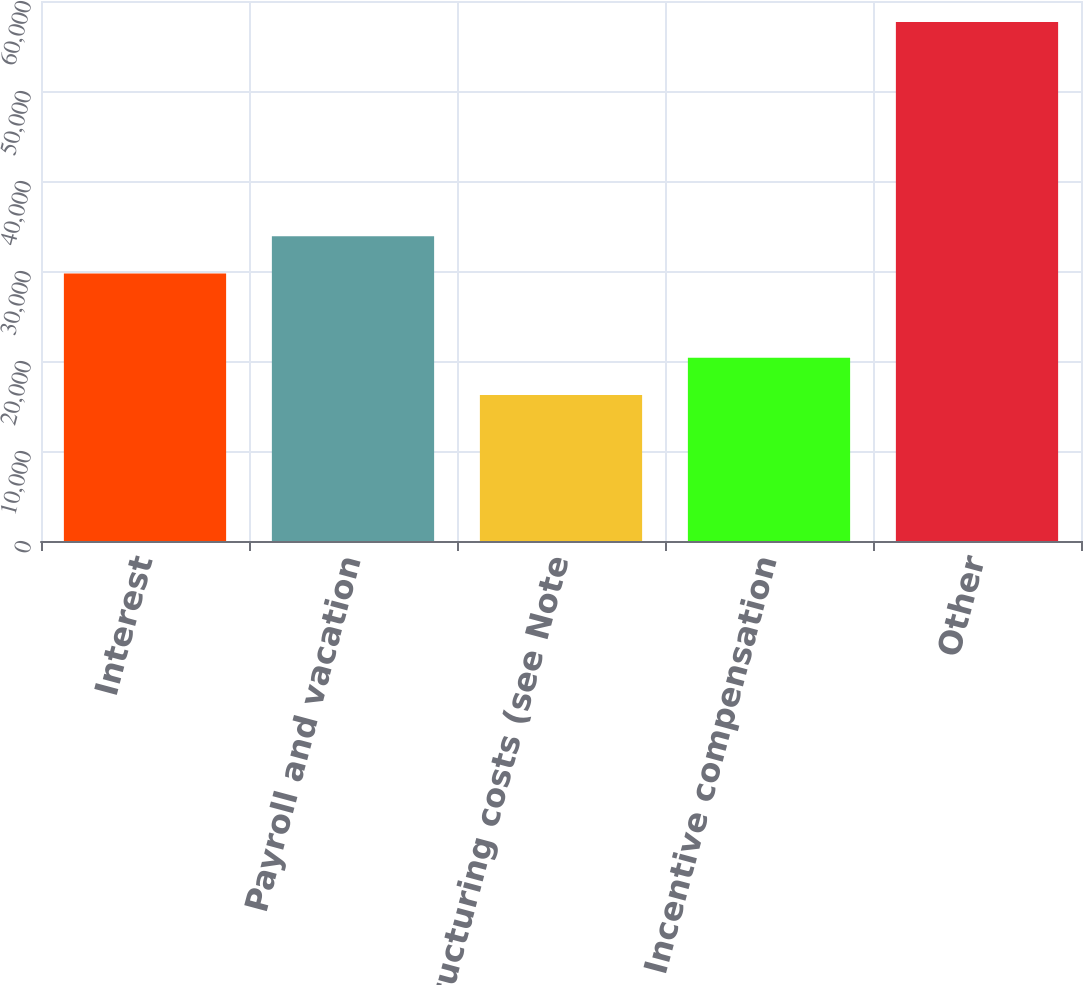Convert chart to OTSL. <chart><loc_0><loc_0><loc_500><loc_500><bar_chart><fcel>Interest<fcel>Payroll and vacation<fcel>Restructuring costs (see Note<fcel>Incentive compensation<fcel>Other<nl><fcel>29715<fcel>33858.3<fcel>16225<fcel>20368.3<fcel>57658<nl></chart> 